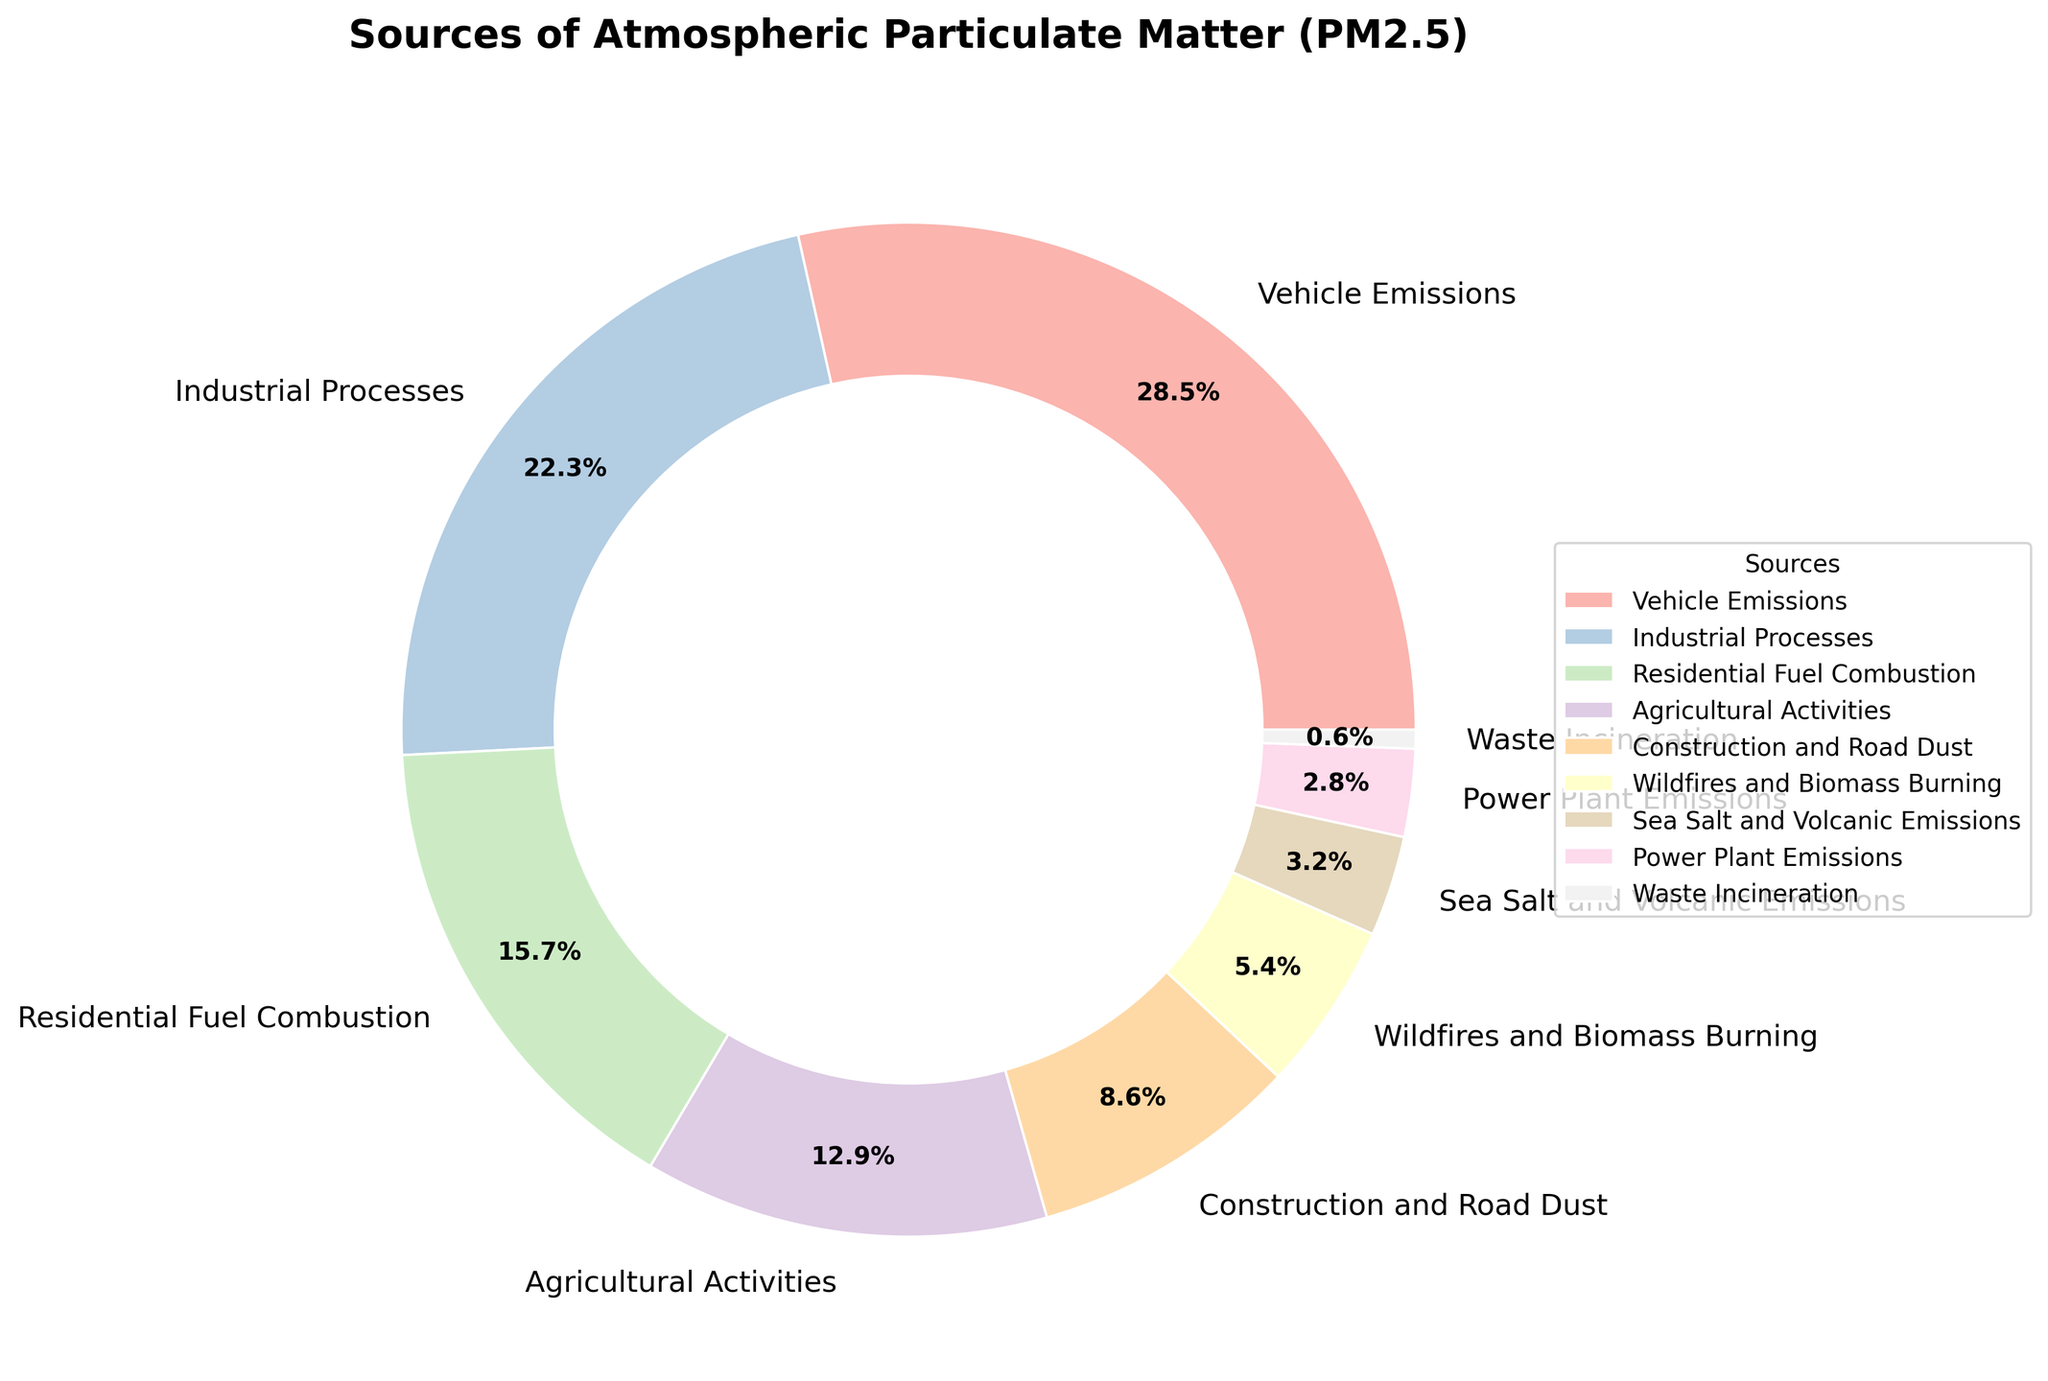What is the source of the highest percentage of atmospheric PM2.5? Vehicle Emissions has the highest percentage. This can be seen at a glance by noting the largest segment in the pie chart, which is labeled with 28.5%.
Answer: Vehicle Emissions Which source contributes more to atmospheric PM2.5, Industrial Processes or Residential Fuel Combustion? The pie chart shows that Industrial Processes contribute 22.3%, while Residential Fuel Combustion contributes 15.7%. Industrial Processes have a higher contribution.
Answer: Industrial Processes What is the combined percentage of PM2.5 from Agricultural Activities and Construction and Road Dust? Agricultural Activities contribute 12.9%, and Construction and Road Dust contribute 8.6%. Adding these together gives 12.9% + 8.6% = 21.5%.
Answer: 21.5% Which source has the lowest contribution to atmospheric PM2.5? Waste Incineration has the smallest segment in the pie chart, labeled with 0.6%, indicating it's the lowest contributor.
Answer: Waste Incineration How much more does Vehicle Emissions contribute to PM2.5 compared to Wildfires and Biomass Burning? Vehicle Emissions contribute 28.5%, while Wildfires and Biomass Burning contribute 5.4%. The difference is 28.5% - 5.4% = 23.1%.
Answer: 23.1% If the contributions of Power Plant Emissions and Sea Salt and Volcanic Emissions are combined, do they surpass Residential Fuel Combustion? Power Plant Emissions contribute 2.8%, and Sea Salt and Volcanic Emissions contribute 3.2%. Combined, this is 2.8% + 3.2% = 6%. This is less than Residential Fuel Combustion, which is 15.7%.
Answer: No What is the visual representation (color) used for the source with the third-highest contribution? The source with the third-highest contribution is Residential Fuel Combustion at 15.7%. The color used for this segment in the pie chart seems pastel green.
Answer: Pastel green Which three sources together contribute more than 50% to atmospheric PM2.5? Adding the top three contributors: Vehicle Emissions (28.5%), Industrial Processes (22.3%), and Residential Fuel Combustion (15.7%). Their combined contribution is 28.5% + 22.3% + 15.7% = 66.5%, which is more than 50%.
Answer: Vehicle Emissions, Industrial Processes, Residential Fuel Combustion How does the contribution of Sea Salt and Volcanic Emissions compare to that of Wildfires and Biomass Burning? Sea Salt and Volcanic Emissions contribute 3.2%, while Wildfires and Biomass Burning contribute 5.4%. Sea Salt and Volcanic Emissions contribute less.
Answer: Sea Salt and Volcanic Emissions contribute less 